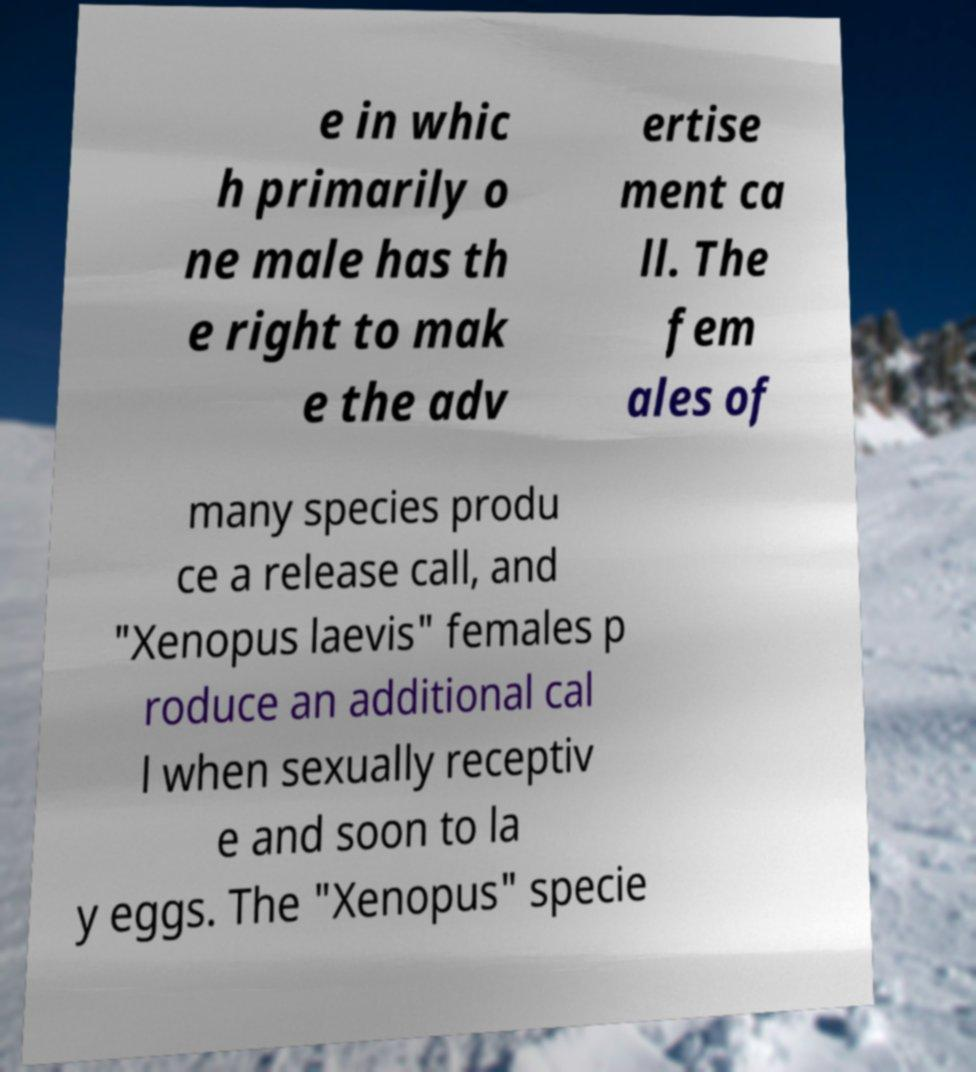What messages or text are displayed in this image? I need them in a readable, typed format. e in whic h primarily o ne male has th e right to mak e the adv ertise ment ca ll. The fem ales of many species produ ce a release call, and "Xenopus laevis" females p roduce an additional cal l when sexually receptiv e and soon to la y eggs. The "Xenopus" specie 